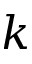<formula> <loc_0><loc_0><loc_500><loc_500>k</formula> 